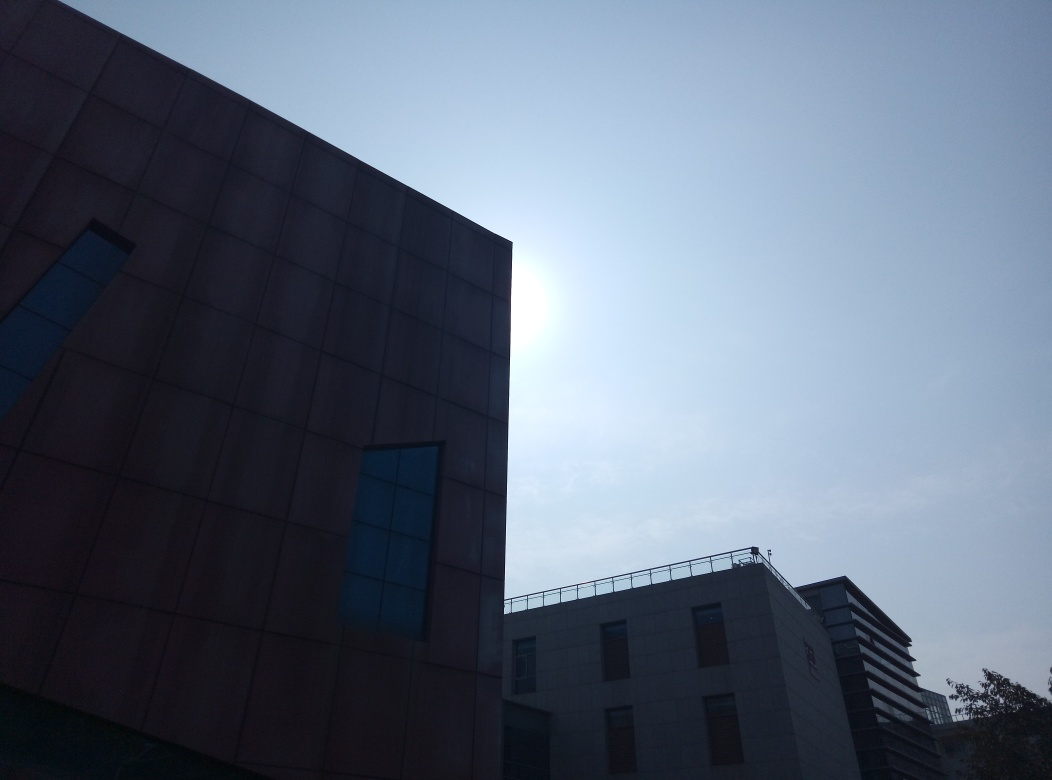Take a detailed look at the image's quality and rate it according to your assessment. While the image shows signs of overexposure and a noticeable soft focus effect around the edges of the building, these elements could be intentional, aiming to create a specific mood or emphasize the contrast between the bright sky and the darker building facade. The image invokes a sense of mystery and obscuring details which may not serve well for utilitarian purposes but offers a distinct stylistic choice that could be appealing in artistic contexts. On a technical level, improvements could be made in terms of sharpness and color balance to achieve more detail and vibrancy. 